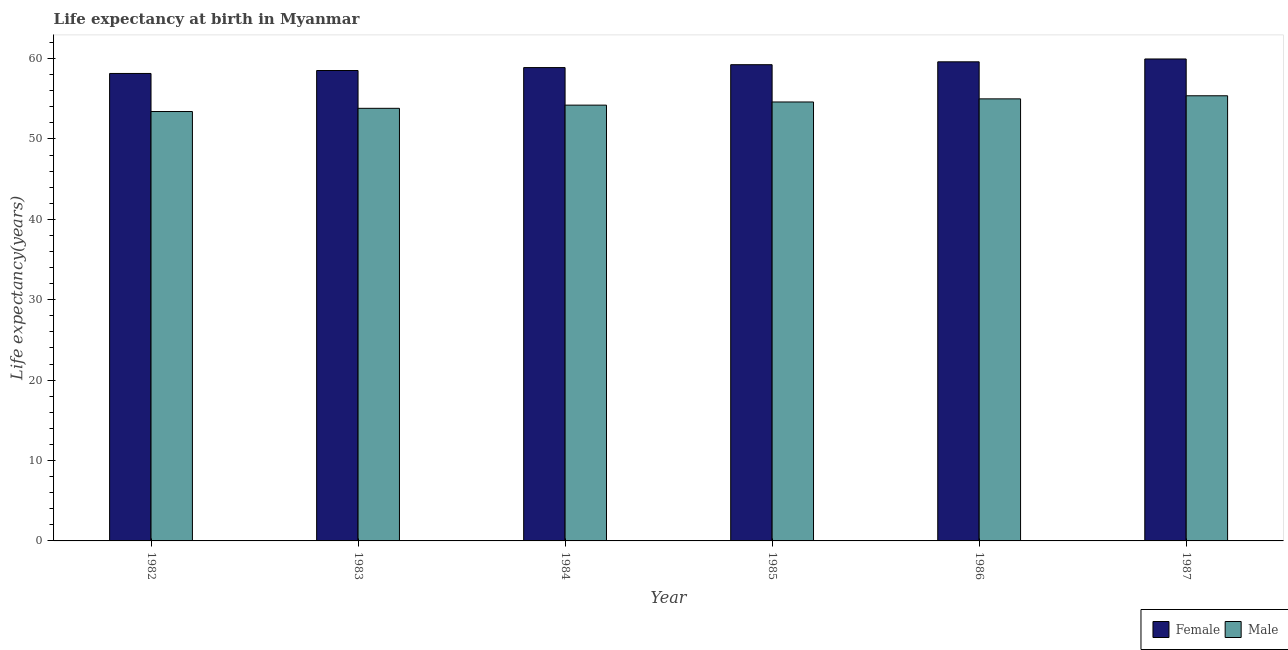Are the number of bars on each tick of the X-axis equal?
Keep it short and to the point. Yes. What is the label of the 3rd group of bars from the left?
Provide a succinct answer. 1984. What is the life expectancy(female) in 1985?
Ensure brevity in your answer.  59.24. Across all years, what is the maximum life expectancy(male)?
Provide a succinct answer. 55.37. Across all years, what is the minimum life expectancy(male)?
Provide a short and direct response. 53.41. What is the total life expectancy(male) in the graph?
Your answer should be compact. 326.4. What is the difference between the life expectancy(male) in 1986 and that in 1987?
Your response must be concise. -0.38. What is the difference between the life expectancy(male) in 1985 and the life expectancy(female) in 1987?
Ensure brevity in your answer.  -0.77. What is the average life expectancy(female) per year?
Offer a very short reply. 59.06. What is the ratio of the life expectancy(male) in 1982 to that in 1986?
Offer a very short reply. 0.97. Is the difference between the life expectancy(female) in 1984 and 1987 greater than the difference between the life expectancy(male) in 1984 and 1987?
Provide a short and direct response. No. What is the difference between the highest and the second highest life expectancy(male)?
Make the answer very short. 0.38. What is the difference between the highest and the lowest life expectancy(male)?
Make the answer very short. 1.96. In how many years, is the life expectancy(male) greater than the average life expectancy(male) taken over all years?
Your answer should be very brief. 3. Is the sum of the life expectancy(male) in 1986 and 1987 greater than the maximum life expectancy(female) across all years?
Provide a succinct answer. Yes. What does the 1st bar from the left in 1985 represents?
Provide a succinct answer. Female. What does the 2nd bar from the right in 1986 represents?
Ensure brevity in your answer.  Female. Are all the bars in the graph horizontal?
Make the answer very short. No. How many years are there in the graph?
Make the answer very short. 6. What is the difference between two consecutive major ticks on the Y-axis?
Provide a succinct answer. 10. Does the graph contain any zero values?
Offer a very short reply. No. How are the legend labels stacked?
Offer a very short reply. Horizontal. What is the title of the graph?
Your response must be concise. Life expectancy at birth in Myanmar. Does "Female population" appear as one of the legend labels in the graph?
Offer a terse response. No. What is the label or title of the Y-axis?
Your answer should be compact. Life expectancy(years). What is the Life expectancy(years) in Female in 1982?
Offer a very short reply. 58.15. What is the Life expectancy(years) of Male in 1982?
Offer a terse response. 53.41. What is the Life expectancy(years) of Female in 1983?
Ensure brevity in your answer.  58.52. What is the Life expectancy(years) of Male in 1983?
Provide a succinct answer. 53.81. What is the Life expectancy(years) in Female in 1984?
Provide a short and direct response. 58.88. What is the Life expectancy(years) of Male in 1984?
Your response must be concise. 54.21. What is the Life expectancy(years) in Female in 1985?
Offer a very short reply. 59.24. What is the Life expectancy(years) of Male in 1985?
Offer a terse response. 54.6. What is the Life expectancy(years) of Female in 1986?
Keep it short and to the point. 59.6. What is the Life expectancy(years) of Male in 1986?
Provide a succinct answer. 54.99. What is the Life expectancy(years) of Female in 1987?
Offer a very short reply. 59.95. What is the Life expectancy(years) of Male in 1987?
Keep it short and to the point. 55.37. Across all years, what is the maximum Life expectancy(years) in Female?
Keep it short and to the point. 59.95. Across all years, what is the maximum Life expectancy(years) of Male?
Ensure brevity in your answer.  55.37. Across all years, what is the minimum Life expectancy(years) in Female?
Provide a succinct answer. 58.15. Across all years, what is the minimum Life expectancy(years) of Male?
Offer a terse response. 53.41. What is the total Life expectancy(years) of Female in the graph?
Your response must be concise. 354.33. What is the total Life expectancy(years) in Male in the graph?
Keep it short and to the point. 326.4. What is the difference between the Life expectancy(years) in Female in 1982 and that in 1983?
Your answer should be compact. -0.37. What is the difference between the Life expectancy(years) in Male in 1982 and that in 1983?
Provide a short and direct response. -0.4. What is the difference between the Life expectancy(years) in Female in 1982 and that in 1984?
Give a very brief answer. -0.73. What is the difference between the Life expectancy(years) of Male in 1982 and that in 1984?
Make the answer very short. -0.8. What is the difference between the Life expectancy(years) in Female in 1982 and that in 1985?
Offer a terse response. -1.09. What is the difference between the Life expectancy(years) of Male in 1982 and that in 1985?
Give a very brief answer. -1.19. What is the difference between the Life expectancy(years) in Female in 1982 and that in 1986?
Your answer should be compact. -1.45. What is the difference between the Life expectancy(years) in Male in 1982 and that in 1986?
Your answer should be compact. -1.57. What is the difference between the Life expectancy(years) in Female in 1982 and that in 1987?
Ensure brevity in your answer.  -1.8. What is the difference between the Life expectancy(years) in Male in 1982 and that in 1987?
Your answer should be compact. -1.96. What is the difference between the Life expectancy(years) in Female in 1983 and that in 1984?
Give a very brief answer. -0.36. What is the difference between the Life expectancy(years) of Male in 1983 and that in 1984?
Offer a terse response. -0.4. What is the difference between the Life expectancy(years) in Female in 1983 and that in 1985?
Offer a very short reply. -0.72. What is the difference between the Life expectancy(years) of Male in 1983 and that in 1985?
Your answer should be very brief. -0.79. What is the difference between the Life expectancy(years) of Female in 1983 and that in 1986?
Provide a succinct answer. -1.08. What is the difference between the Life expectancy(years) of Male in 1983 and that in 1986?
Keep it short and to the point. -1.18. What is the difference between the Life expectancy(years) in Female in 1983 and that in 1987?
Your answer should be compact. -1.44. What is the difference between the Life expectancy(years) of Male in 1983 and that in 1987?
Make the answer very short. -1.56. What is the difference between the Life expectancy(years) in Female in 1984 and that in 1985?
Provide a short and direct response. -0.36. What is the difference between the Life expectancy(years) of Male in 1984 and that in 1985?
Make the answer very short. -0.39. What is the difference between the Life expectancy(years) in Female in 1984 and that in 1986?
Your answer should be compact. -0.72. What is the difference between the Life expectancy(years) of Male in 1984 and that in 1986?
Offer a terse response. -0.78. What is the difference between the Life expectancy(years) in Female in 1984 and that in 1987?
Your answer should be compact. -1.07. What is the difference between the Life expectancy(years) of Male in 1984 and that in 1987?
Your answer should be very brief. -1.16. What is the difference between the Life expectancy(years) in Female in 1985 and that in 1986?
Your response must be concise. -0.36. What is the difference between the Life expectancy(years) in Male in 1985 and that in 1986?
Offer a terse response. -0.39. What is the difference between the Life expectancy(years) in Female in 1985 and that in 1987?
Make the answer very short. -0.71. What is the difference between the Life expectancy(years) in Male in 1985 and that in 1987?
Make the answer very short. -0.77. What is the difference between the Life expectancy(years) in Female in 1986 and that in 1987?
Keep it short and to the point. -0.35. What is the difference between the Life expectancy(years) in Male in 1986 and that in 1987?
Ensure brevity in your answer.  -0.38. What is the difference between the Life expectancy(years) in Female in 1982 and the Life expectancy(years) in Male in 1983?
Offer a very short reply. 4.33. What is the difference between the Life expectancy(years) in Female in 1982 and the Life expectancy(years) in Male in 1984?
Your answer should be very brief. 3.94. What is the difference between the Life expectancy(years) in Female in 1982 and the Life expectancy(years) in Male in 1985?
Make the answer very short. 3.55. What is the difference between the Life expectancy(years) of Female in 1982 and the Life expectancy(years) of Male in 1986?
Ensure brevity in your answer.  3.16. What is the difference between the Life expectancy(years) in Female in 1982 and the Life expectancy(years) in Male in 1987?
Make the answer very short. 2.77. What is the difference between the Life expectancy(years) in Female in 1983 and the Life expectancy(years) in Male in 1984?
Give a very brief answer. 4.31. What is the difference between the Life expectancy(years) in Female in 1983 and the Life expectancy(years) in Male in 1985?
Your answer should be very brief. 3.92. What is the difference between the Life expectancy(years) in Female in 1983 and the Life expectancy(years) in Male in 1986?
Your answer should be compact. 3.53. What is the difference between the Life expectancy(years) of Female in 1983 and the Life expectancy(years) of Male in 1987?
Make the answer very short. 3.14. What is the difference between the Life expectancy(years) of Female in 1984 and the Life expectancy(years) of Male in 1985?
Your answer should be compact. 4.28. What is the difference between the Life expectancy(years) of Female in 1984 and the Life expectancy(years) of Male in 1986?
Make the answer very short. 3.89. What is the difference between the Life expectancy(years) in Female in 1984 and the Life expectancy(years) in Male in 1987?
Provide a succinct answer. 3.51. What is the difference between the Life expectancy(years) of Female in 1985 and the Life expectancy(years) of Male in 1986?
Provide a short and direct response. 4.25. What is the difference between the Life expectancy(years) in Female in 1985 and the Life expectancy(years) in Male in 1987?
Your answer should be very brief. 3.87. What is the difference between the Life expectancy(years) of Female in 1986 and the Life expectancy(years) of Male in 1987?
Provide a short and direct response. 4.22. What is the average Life expectancy(years) of Female per year?
Your answer should be very brief. 59.06. What is the average Life expectancy(years) of Male per year?
Your answer should be compact. 54.4. In the year 1982, what is the difference between the Life expectancy(years) of Female and Life expectancy(years) of Male?
Your answer should be compact. 4.73. In the year 1983, what is the difference between the Life expectancy(years) in Female and Life expectancy(years) in Male?
Give a very brief answer. 4.7. In the year 1984, what is the difference between the Life expectancy(years) in Female and Life expectancy(years) in Male?
Offer a very short reply. 4.67. In the year 1985, what is the difference between the Life expectancy(years) in Female and Life expectancy(years) in Male?
Give a very brief answer. 4.64. In the year 1986, what is the difference between the Life expectancy(years) of Female and Life expectancy(years) of Male?
Your response must be concise. 4.61. In the year 1987, what is the difference between the Life expectancy(years) in Female and Life expectancy(years) in Male?
Keep it short and to the point. 4.58. What is the ratio of the Life expectancy(years) in Male in 1982 to that in 1983?
Offer a very short reply. 0.99. What is the ratio of the Life expectancy(years) of Female in 1982 to that in 1984?
Provide a succinct answer. 0.99. What is the ratio of the Life expectancy(years) of Male in 1982 to that in 1984?
Ensure brevity in your answer.  0.99. What is the ratio of the Life expectancy(years) in Female in 1982 to that in 1985?
Provide a succinct answer. 0.98. What is the ratio of the Life expectancy(years) in Male in 1982 to that in 1985?
Make the answer very short. 0.98. What is the ratio of the Life expectancy(years) in Female in 1982 to that in 1986?
Provide a short and direct response. 0.98. What is the ratio of the Life expectancy(years) of Male in 1982 to that in 1986?
Your response must be concise. 0.97. What is the ratio of the Life expectancy(years) of Female in 1982 to that in 1987?
Provide a short and direct response. 0.97. What is the ratio of the Life expectancy(years) in Male in 1982 to that in 1987?
Offer a very short reply. 0.96. What is the ratio of the Life expectancy(years) of Male in 1983 to that in 1984?
Keep it short and to the point. 0.99. What is the ratio of the Life expectancy(years) in Male in 1983 to that in 1985?
Offer a very short reply. 0.99. What is the ratio of the Life expectancy(years) of Female in 1983 to that in 1986?
Keep it short and to the point. 0.98. What is the ratio of the Life expectancy(years) of Male in 1983 to that in 1986?
Your response must be concise. 0.98. What is the ratio of the Life expectancy(years) of Female in 1983 to that in 1987?
Ensure brevity in your answer.  0.98. What is the ratio of the Life expectancy(years) of Male in 1983 to that in 1987?
Make the answer very short. 0.97. What is the ratio of the Life expectancy(years) in Male in 1984 to that in 1985?
Ensure brevity in your answer.  0.99. What is the ratio of the Life expectancy(years) in Male in 1984 to that in 1986?
Keep it short and to the point. 0.99. What is the ratio of the Life expectancy(years) in Female in 1984 to that in 1987?
Ensure brevity in your answer.  0.98. What is the ratio of the Life expectancy(years) in Male in 1984 to that in 1987?
Offer a very short reply. 0.98. What is the ratio of the Life expectancy(years) of Male in 1985 to that in 1987?
Offer a very short reply. 0.99. What is the difference between the highest and the second highest Life expectancy(years) in Female?
Offer a terse response. 0.35. What is the difference between the highest and the second highest Life expectancy(years) in Male?
Keep it short and to the point. 0.38. What is the difference between the highest and the lowest Life expectancy(years) in Female?
Your answer should be compact. 1.8. What is the difference between the highest and the lowest Life expectancy(years) of Male?
Your answer should be compact. 1.96. 